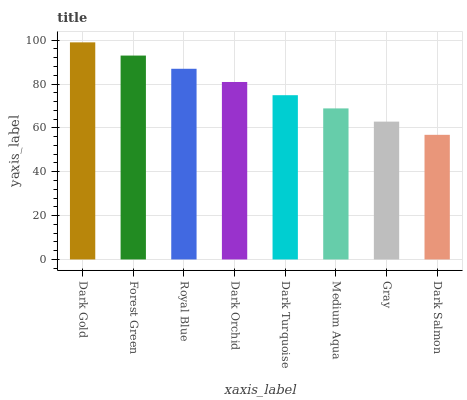Is Forest Green the minimum?
Answer yes or no. No. Is Forest Green the maximum?
Answer yes or no. No. Is Dark Gold greater than Forest Green?
Answer yes or no. Yes. Is Forest Green less than Dark Gold?
Answer yes or no. Yes. Is Forest Green greater than Dark Gold?
Answer yes or no. No. Is Dark Gold less than Forest Green?
Answer yes or no. No. Is Dark Orchid the high median?
Answer yes or no. Yes. Is Dark Turquoise the low median?
Answer yes or no. Yes. Is Dark Turquoise the high median?
Answer yes or no. No. Is Dark Orchid the low median?
Answer yes or no. No. 